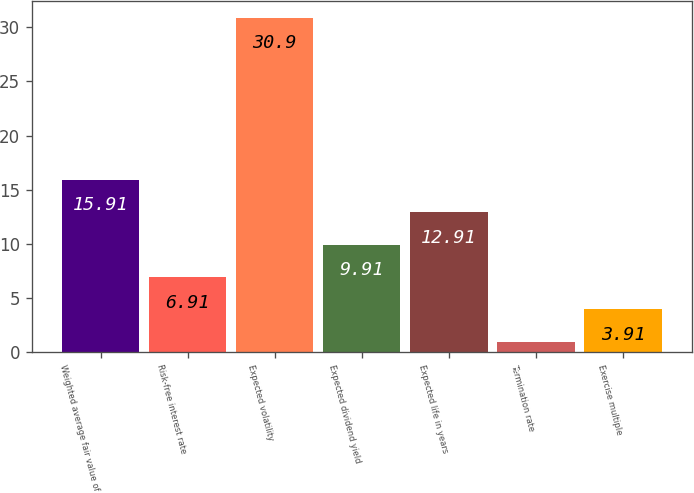Convert chart to OTSL. <chart><loc_0><loc_0><loc_500><loc_500><bar_chart><fcel>Weighted average fair value of<fcel>Risk-free interest rate<fcel>Expected volatility<fcel>Expected dividend yield<fcel>Expected life in years<fcel>Termination rate<fcel>Exercise multiple<nl><fcel>15.91<fcel>6.91<fcel>30.9<fcel>9.91<fcel>12.91<fcel>0.91<fcel>3.91<nl></chart> 